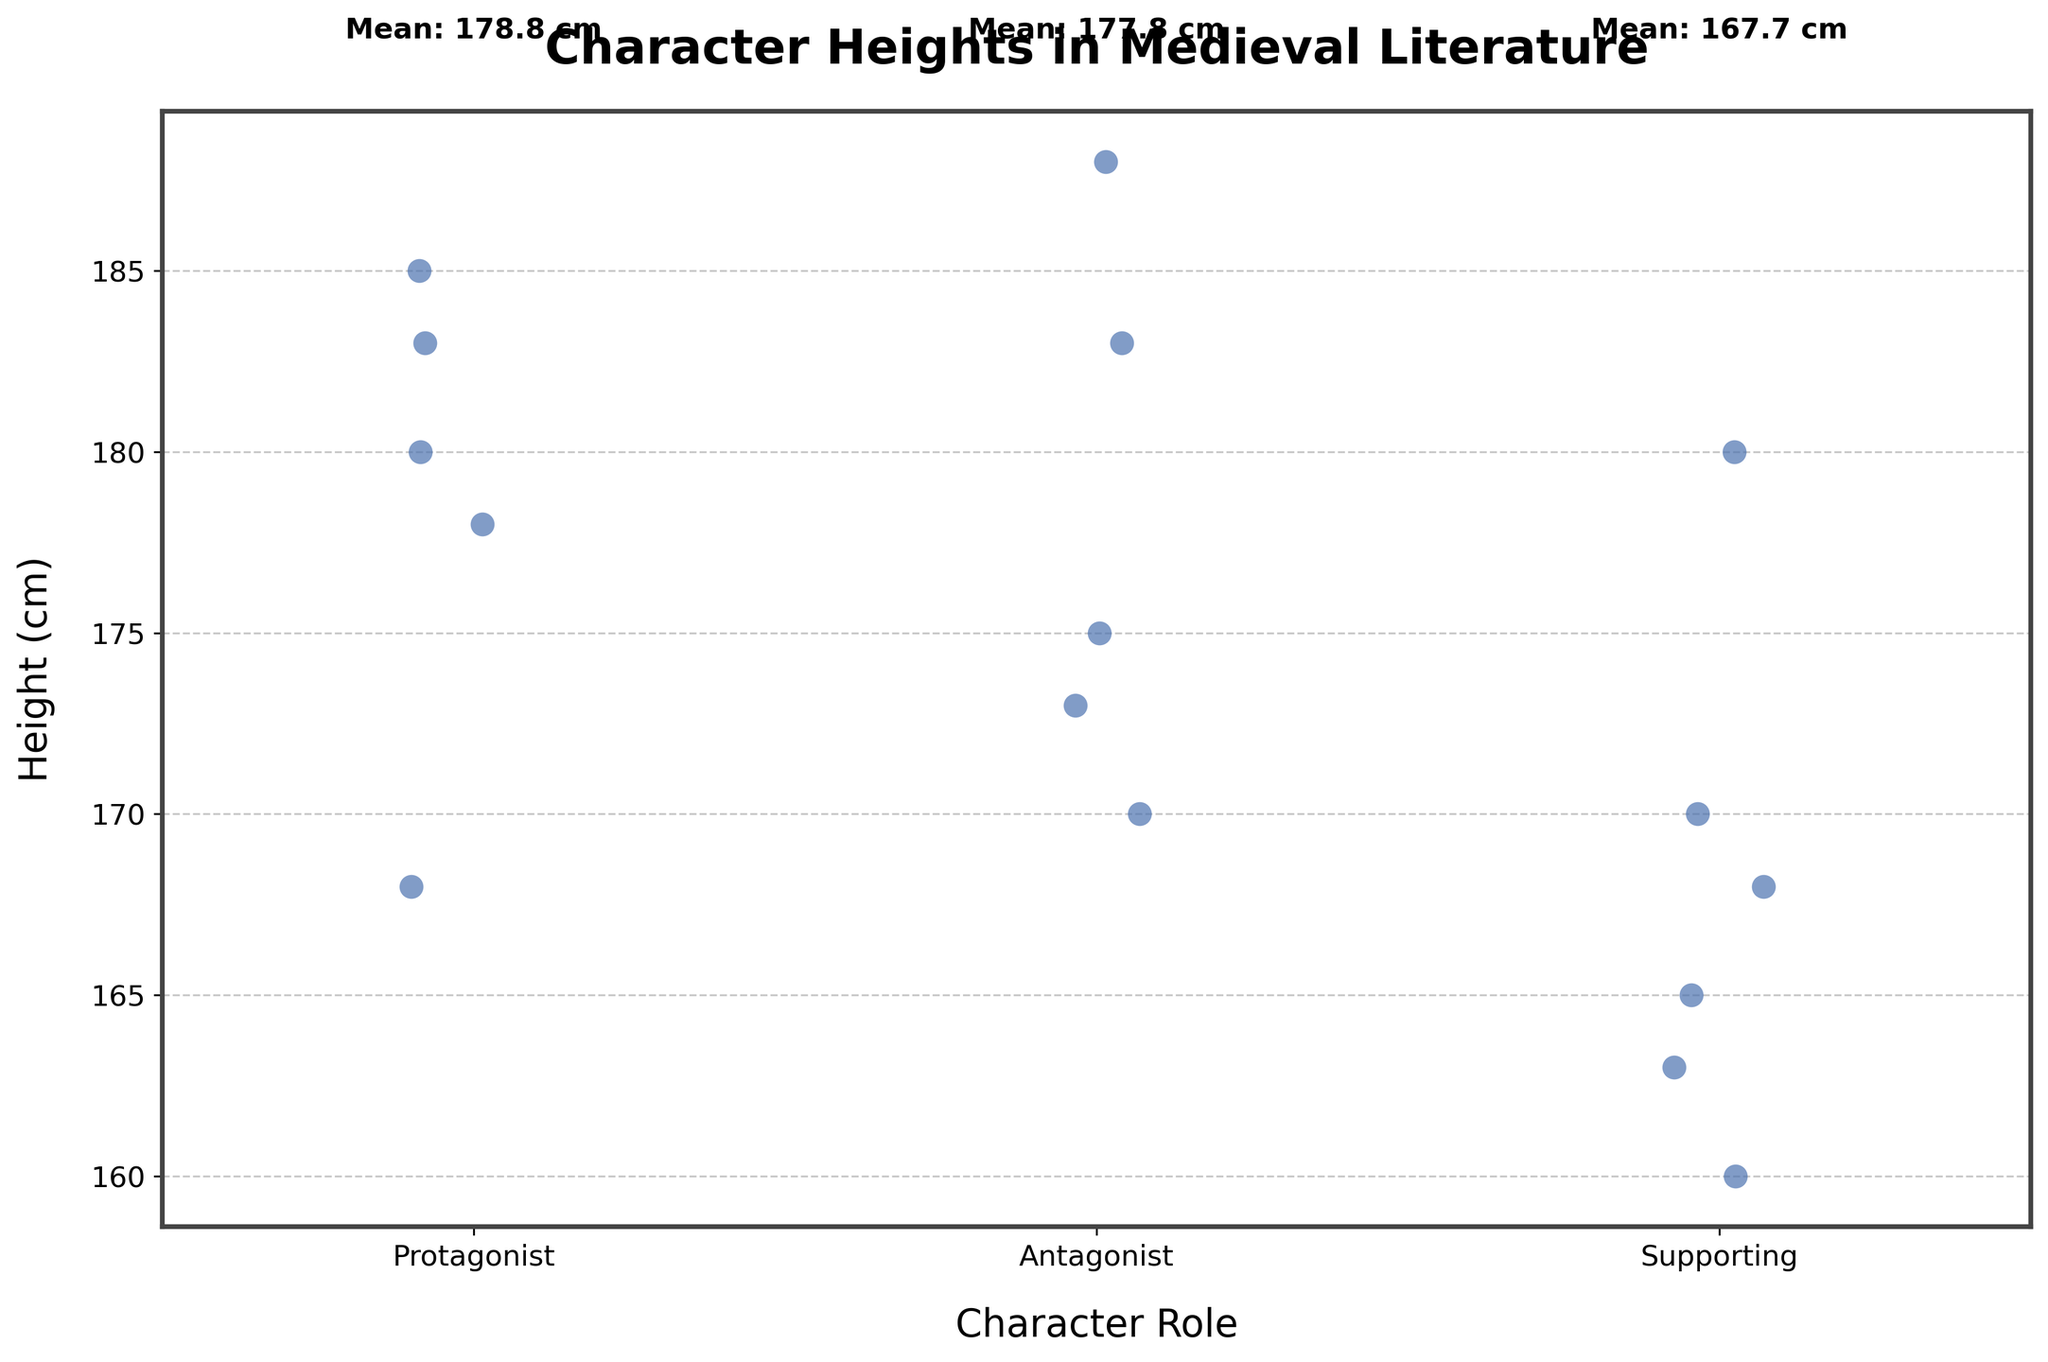What is the title of the figure? The title appears at the top of the figure in bold text. It reads "Character Heights in Medieval Literature."
Answer: Character Heights in Medieval Literature How many roles are represented in the figure? The x-axis of the figure shows different roles being compared. There are three distinct roles: Protagonist, Antagonist, and Supporting.
Answer: 3 What is the y-axis label in the figure? The y-axis label appears vertically on the left side of the figure. It reads "Height (cm)."
Answer: Height (cm) What is the mean height of protagonists? The mean height of protagonists is displayed above the "Protagonist" category on the x-axis. It reads "Mean: 178.8 cm."
Answer: 178.8 cm Which character role has the highest average height? By examining the text annotations above each role category, the "Protagonist" has the highest average height at 178.8 cm, "Antagonist" at 178.5 cm, and "Supporting" at 167.7 cm.
Answer: Protagonist Which character role has the lowest point on the y-axis? The lowest point on the y-axis corresponds to the smallest height in each role. The "Supporting" role has the lowest point at 160 cm.
Answer: Supporting How does the average height of antagonists compare to protagonists? The mean height of antagonists (178.5 cm) compared to protagonists (178.8 cm) can be interpreted directly from the text annotations above each role. Protagonists have a slightly higher average height.
Answer: Protagonists are slightly taller How many characters are in the protagonist role? By counting the individual data points (markers) in the protagonist group, we can determine there are four data points in the protagonist category.
Answer: 4 What is the range of heights for supporting characters? The range can be determined by subtracting the smallest height from the largest height within the supporting group. The smallest is 160 cm, and the largest is 180 cm, so the range is 20 cm.
Answer: 20 cm Based on the figure, which character category has the most diverse range of heights? By visually inspecting the spread of data points along the y-axis for each category, "Supporting" characters have a more diverse range (spanning from 160 cm to 180 cm), in comparison to other categories.
Answer: Supporting 